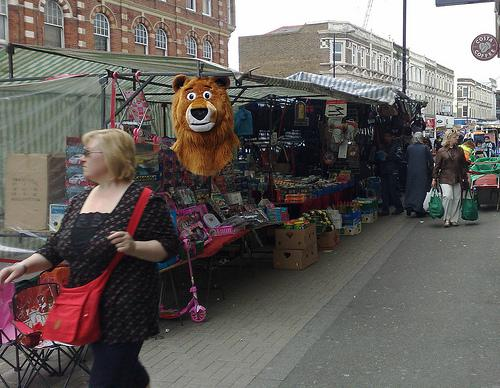Question: what are the people doing in this picture?
Choices:
A. Shopping for items.
B. Playing basketball.
C. Cooking dinner.
D. Selling cookies.
Answer with the letter. Answer: A Question: where is this picture taken?
Choices:
A. On a street.
B. At a park.
C. At the gym.
D. At the mall.
Answer with the letter. Answer: A Question: why are the people walking?
Choices:
A. They are heading towards the zoo.
B. They are crossing the street.
C. They are looking for rabbits.
D. They are looking at the different items there are being sold.
Answer with the letter. Answer: D Question: how many green bags does the woman in the back have?
Choices:
A. 9.
B. 2.
C. 8.
D. 7.
Answer with the letter. Answer: B 